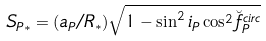Convert formula to latex. <formula><loc_0><loc_0><loc_500><loc_500>S _ { P * } & = ( a _ { P } / R _ { * } ) \sqrt { 1 - \sin ^ { 2 } i _ { P } \cos ^ { 2 } \breve { f } _ { P } ^ { c i r c } }</formula> 